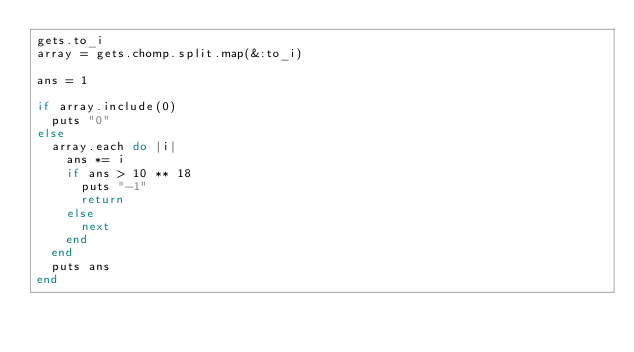Convert code to text. <code><loc_0><loc_0><loc_500><loc_500><_Ruby_>gets.to_i
array = gets.chomp.split.map(&:to_i)

ans = 1

if array.include(0)
  puts "0"
else
  array.each do |i|
    ans *= i
    if ans > 10 ** 18
      puts "-1"
      return
    else
      next
    end
  end
  puts ans
end
</code> 